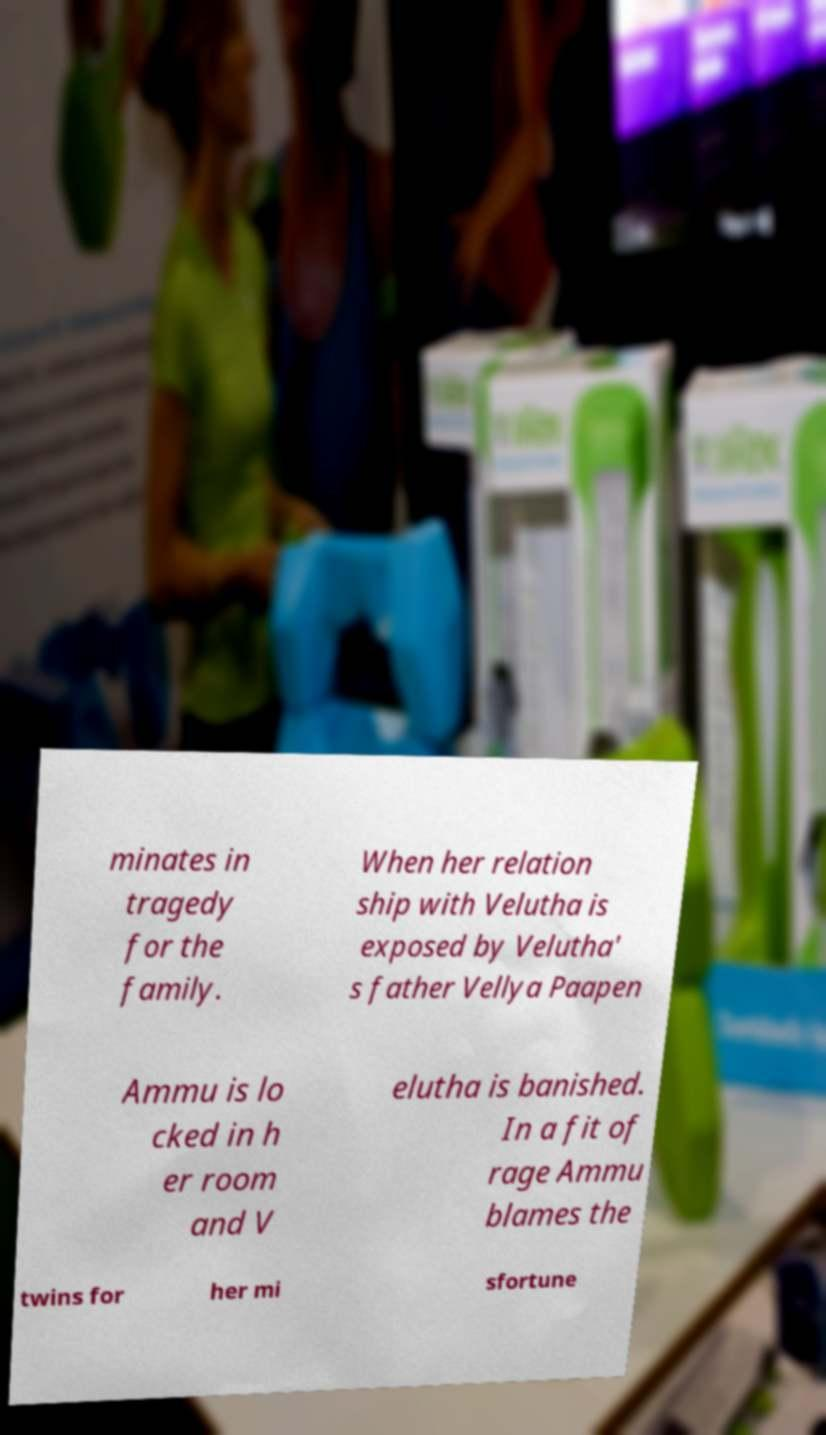There's text embedded in this image that I need extracted. Can you transcribe it verbatim? minates in tragedy for the family. When her relation ship with Velutha is exposed by Velutha' s father Vellya Paapen Ammu is lo cked in h er room and V elutha is banished. In a fit of rage Ammu blames the twins for her mi sfortune 